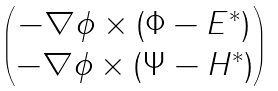<formula> <loc_0><loc_0><loc_500><loc_500>\begin{pmatrix} - \nabla \phi \times ( \Phi - E ^ { \ast } ) \\ - \nabla \phi \times ( \Psi - H ^ { \ast } ) \end{pmatrix}</formula> 